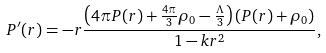Convert formula to latex. <formula><loc_0><loc_0><loc_500><loc_500>P ^ { \prime } ( r ) = - r \frac { \left ( 4 \pi P ( r ) + \frac { 4 \pi } { 3 } \rho _ { 0 } - \frac { \Lambda } { 3 } \right ) \left ( P ( r ) + \rho _ { 0 } \right ) } { 1 - k r ^ { 2 } } ,</formula> 